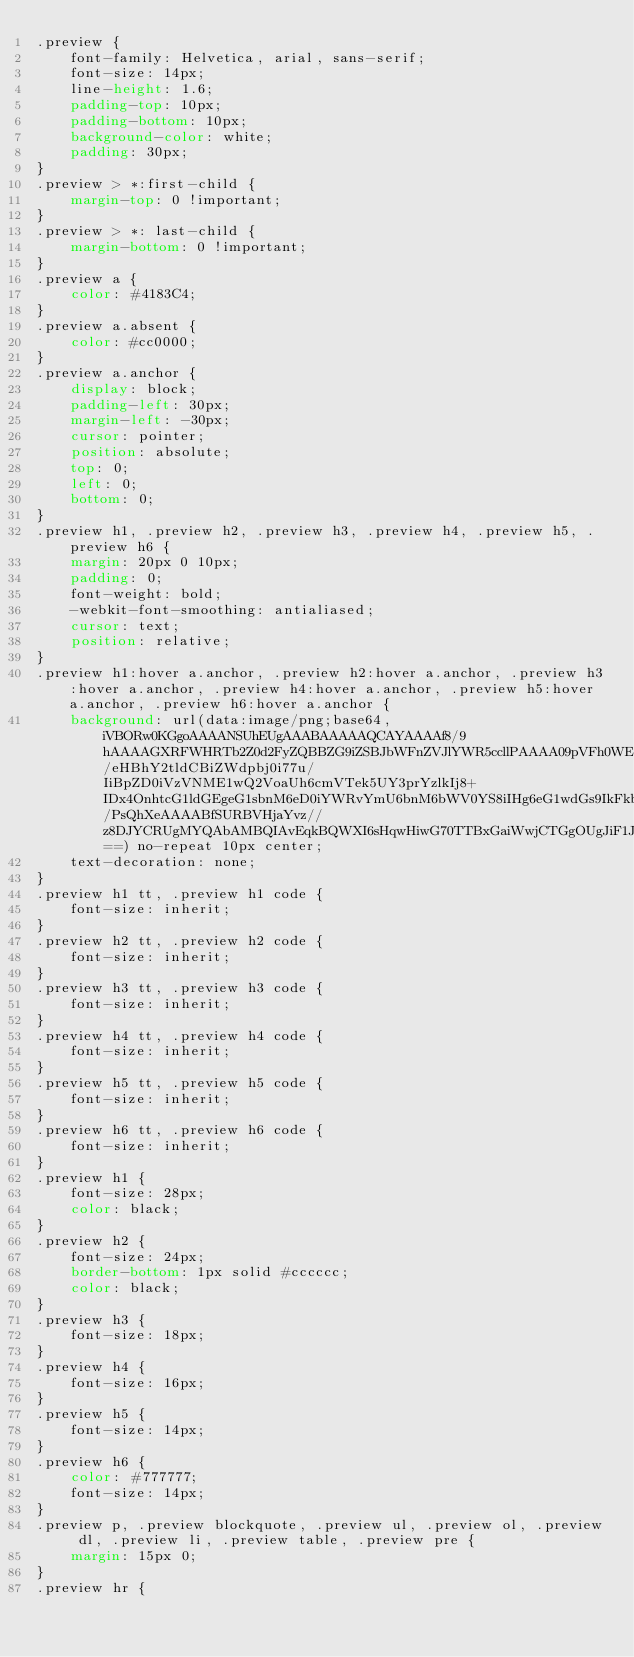<code> <loc_0><loc_0><loc_500><loc_500><_CSS_>.preview {
    font-family: Helvetica, arial, sans-serif;
    font-size: 14px;
    line-height: 1.6;
    padding-top: 10px;
    padding-bottom: 10px;
    background-color: white;
    padding: 30px;
}
.preview > *:first-child {
    margin-top: 0 !important;
}
.preview > *: last-child {
    margin-bottom: 0 !important;
}
.preview a {
    color: #4183C4;
}
.preview a.absent {
    color: #cc0000;
}
.preview a.anchor {
    display: block;
    padding-left: 30px;
    margin-left: -30px;
    cursor: pointer;
    position: absolute;
    top: 0;
    left: 0;
    bottom: 0;
}
.preview h1, .preview h2, .preview h3, .preview h4, .preview h5, .preview h6 {
    margin: 20px 0 10px;
    padding: 0;
    font-weight: bold;
    -webkit-font-smoothing: antialiased;
    cursor: text;
    position: relative;
}
.preview h1:hover a.anchor, .preview h2:hover a.anchor, .preview h3:hover a.anchor, .preview h4:hover a.anchor, .preview h5:hover a.anchor, .preview h6:hover a.anchor {
    background: url(data:image/png;base64,iVBORw0KGgoAAAANSUhEUgAAABAAAAAQCAYAAAAf8/9hAAAAGXRFWHRTb2Z0d2FyZQBBZG9iZSBJbWFnZVJlYWR5ccllPAAAA09pVFh0WE1MOmNvbS5hZG9iZS54bXAAAAAAADw/eHBhY2tldCBiZWdpbj0i77u/IiBpZD0iVzVNME1wQ2VoaUh6cmVTek5UY3prYzlkIj8+IDx4OnhtcG1ldGEgeG1sbnM6eD0iYWRvYmU6bnM6bWV0YS8iIHg6eG1wdGs9IkFkb2JlIFhNUCBDb3JlIDUuMy1jMDExIDY2LjE0NTY2MSwgMjAxMi8wMi8wNi0xNDo1NjoyNyAgICAgICAgIj4gPHJkZjpSREYgeG1sbnM6cmRmPSJodHRwOi8vd3d3LnczLm9yZy8xOTk5LzAyLzIyLXJkZi1zeW50YXgtbnMjIj4gPHJkZjpEZXNjcmlwdGlvbiByZGY6YWJvdXQ9IiIgeG1sbnM6eG1wPSJodHRwOi8vbnMuYWRvYmUuY29tL3hhcC8xLjAvIiB4bWxuczp4bXBNTT0iaHR0cDovL25zLmFkb2JlLmNvbS94YXAvMS4wL21tLyIgeG1sbnM6c3RSZWY9Imh0dHA6Ly9ucy5hZG9iZS5jb20veGFwLzEuMC9zVHlwZS9SZXNvdXJjZVJlZiMiIHhtcDpDcmVhdG9yVG9vbD0iQWRvYmUgUGhvdG9zaG9wIENTNiAoMTMuMCAyMDEyMDMwNS5tLjQxNSAyMDEyLzAzLzA1OjIxOjAwOjAwKSAgKE1hY2ludG9zaCkiIHhtcE1NOkluc3RhbmNlSUQ9InhtcC5paWQ6OUM2NjlDQjI4ODBGMTFFMTg1ODlEODNERDJBRjUwQTQiIHhtcE1NOkRvY3VtZW50SUQ9InhtcC5kaWQ6OUM2NjlDQjM4ODBGMTFFMTg1ODlEODNERDJBRjUwQTQiPiA8eG1wTU06RGVyaXZlZEZyb20gc3RSZWY6aW5zdGFuY2VJRD0ieG1wLmlpZDo5QzY2OUNCMDg4MEYxMUUxODU4OUQ4M0REMkFGNTBBNCIgc3RSZWY6ZG9jdW1lbnRJRD0ieG1wLmRpZDo5QzY2OUNCMTg4MEYxMUUxODU4OUQ4M0REMkFGNTBBNCIvPiA8L3JkZjpEZXNjcmlwdGlvbj4gPC9yZGY6UkRGPiA8L3g6eG1wbWV0YT4gPD94cGFja2V0IGVuZD0iciI/PsQhXeAAAABfSURBVHjaYvz//z8DJYCRUgMYQAbAMBQIAvEqkBQWXI6sHqwHiwG70TTBxGaiWwjCTGgOUgJiF1J8wMRAIUA34B4Q76HUBelAfJYSA0CuMIEaRP8wGIkGMA54bgQIMACAmkXJi0hKJQAAAABJRU5ErkJggg==) no-repeat 10px center;
    text-decoration: none;
}
.preview h1 tt, .preview h1 code {
    font-size: inherit;
}
.preview h2 tt, .preview h2 code {
    font-size: inherit;
}
.preview h3 tt, .preview h3 code {
    font-size: inherit;
}
.preview h4 tt, .preview h4 code {
    font-size: inherit;
}
.preview h5 tt, .preview h5 code {
    font-size: inherit;
}
.preview h6 tt, .preview h6 code {
    font-size: inherit;
}
.preview h1 {
    font-size: 28px;
    color: black;
}
.preview h2 {
    font-size: 24px;
    border-bottom: 1px solid #cccccc;
    color: black;
}
.preview h3 {
    font-size: 18px;
}
.preview h4 {
    font-size: 16px;
}
.preview h5 {
    font-size: 14px;
}
.preview h6 {
    color: #777777;
    font-size: 14px;
}
.preview p, .preview blockquote, .preview ul, .preview ol, .preview dl, .preview li, .preview table, .preview pre {
    margin: 15px 0;
}
.preview hr {</code> 